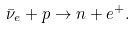<formula> <loc_0><loc_0><loc_500><loc_500>\bar { \nu } _ { e } + p \rightarrow n + e ^ { + } .</formula> 